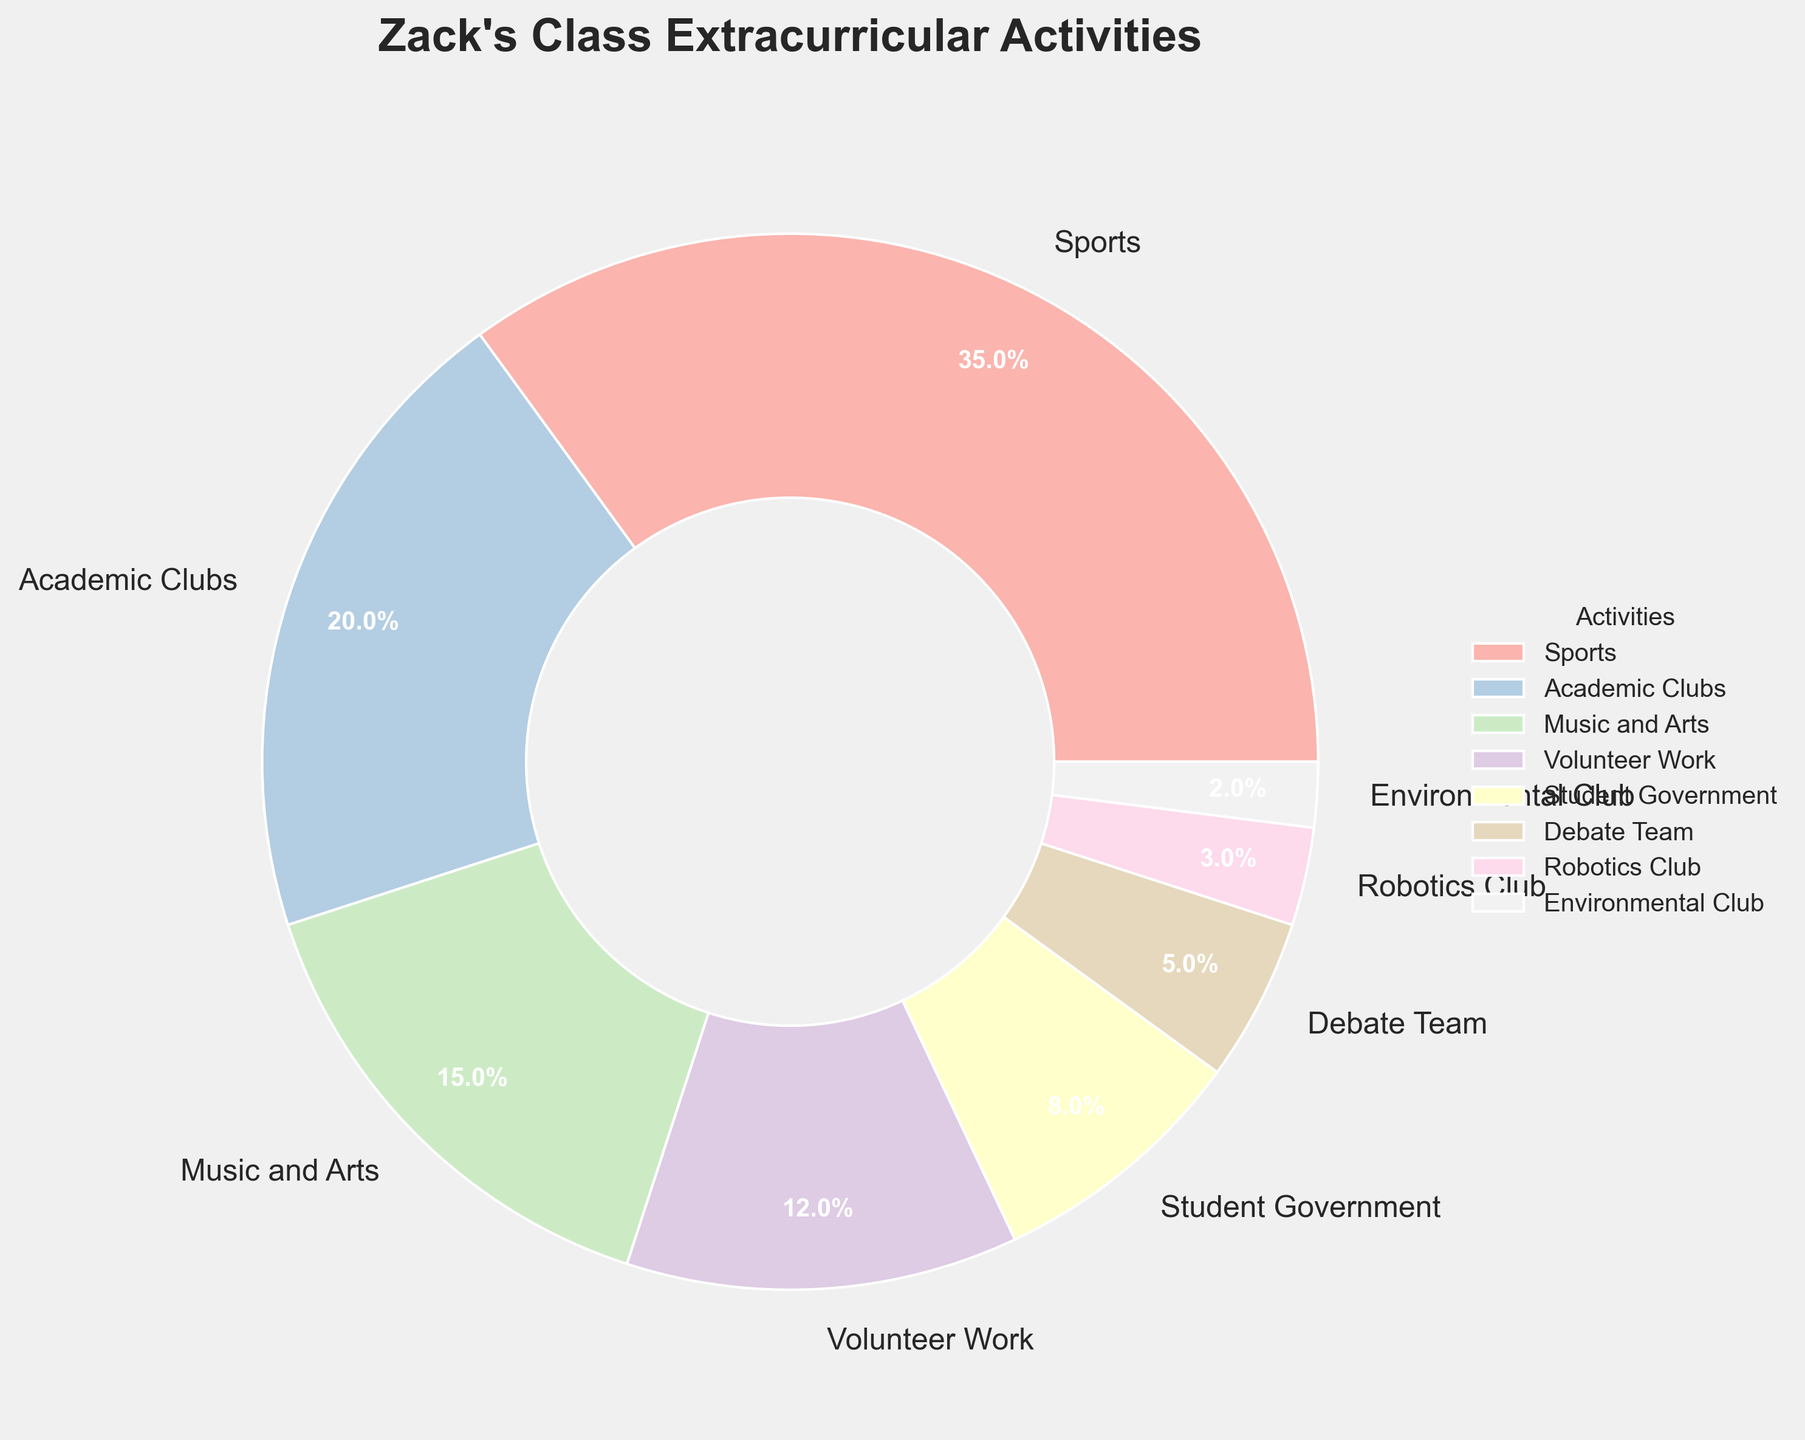Which activity has the highest participation percentage? The figure shows the breakdown of extracurricular activities with their corresponding percentages. The activity with the highest percentage will have the largest pie slice.
Answer: Sports What is the combined percentage of students participating in Music and Arts and Debate Team? To find the combined percentage, sum up the individual percentages for Music and Arts and Debate Team. Music and Arts is 15% and Debate Team is 5%, so 15% + 5% = 20%.
Answer: 20% Which activity has a higher participation rate: Volunteer Work or Student Government? By comparing the slices for Volunteer Work and Student Government, we can see their respective percentages. Volunteer Work is at 12%, while Student Government is at 8%.
Answer: Volunteer Work What percentage of students are involved in activities that are categorized under clubs (Academic Clubs, Robotics Club, Environmental Club)? Sum the percentages for Academic Clubs, Robotics Club, and Environmental Club. 20% + 3% + 2% = 25%.
Answer: 25% How does the participation in Sports compare to the total of the other activities combined? Participation in Sports is 35%. To compare, sum the percentages of all other activities: 20% (Academic Clubs) + 15% (Music and Arts) + 12% (Volunteer Work) + 8% (Student Government) + 5% (Debate Team) + 3% (Robotics Club) + 2% (Environmental Club). This gives 65%. So, Sports is 35%, while all other activities combined are 65%.
Answer: 35% (Sports) vs 65% (Others) What is the least popular extracurricular activity among Zack's class? The least popular activity will have the smallest slice in the pie chart. The Environmental Club has the smallest percentage of 2%.
Answer: Environmental Club 